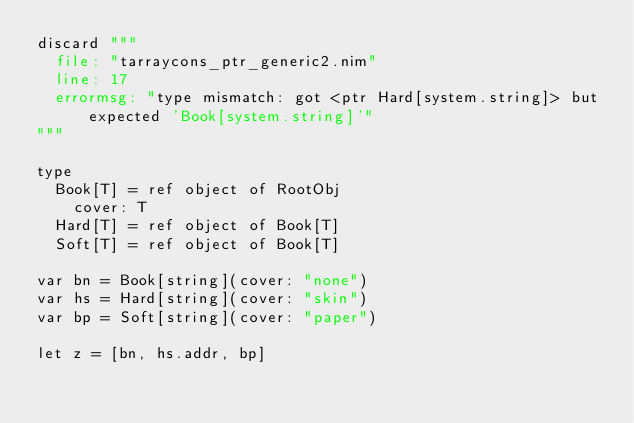Convert code to text. <code><loc_0><loc_0><loc_500><loc_500><_Nim_>discard """
  file: "tarraycons_ptr_generic2.nim"
  line: 17
  errormsg: "type mismatch: got <ptr Hard[system.string]> but expected 'Book[system.string]'"
"""

type
  Book[T] = ref object of RootObj
    cover: T
  Hard[T] = ref object of Book[T]
  Soft[T] = ref object of Book[T]

var bn = Book[string](cover: "none")
var hs = Hard[string](cover: "skin")
var bp = Soft[string](cover: "paper")

let z = [bn, hs.addr, bp]
</code> 